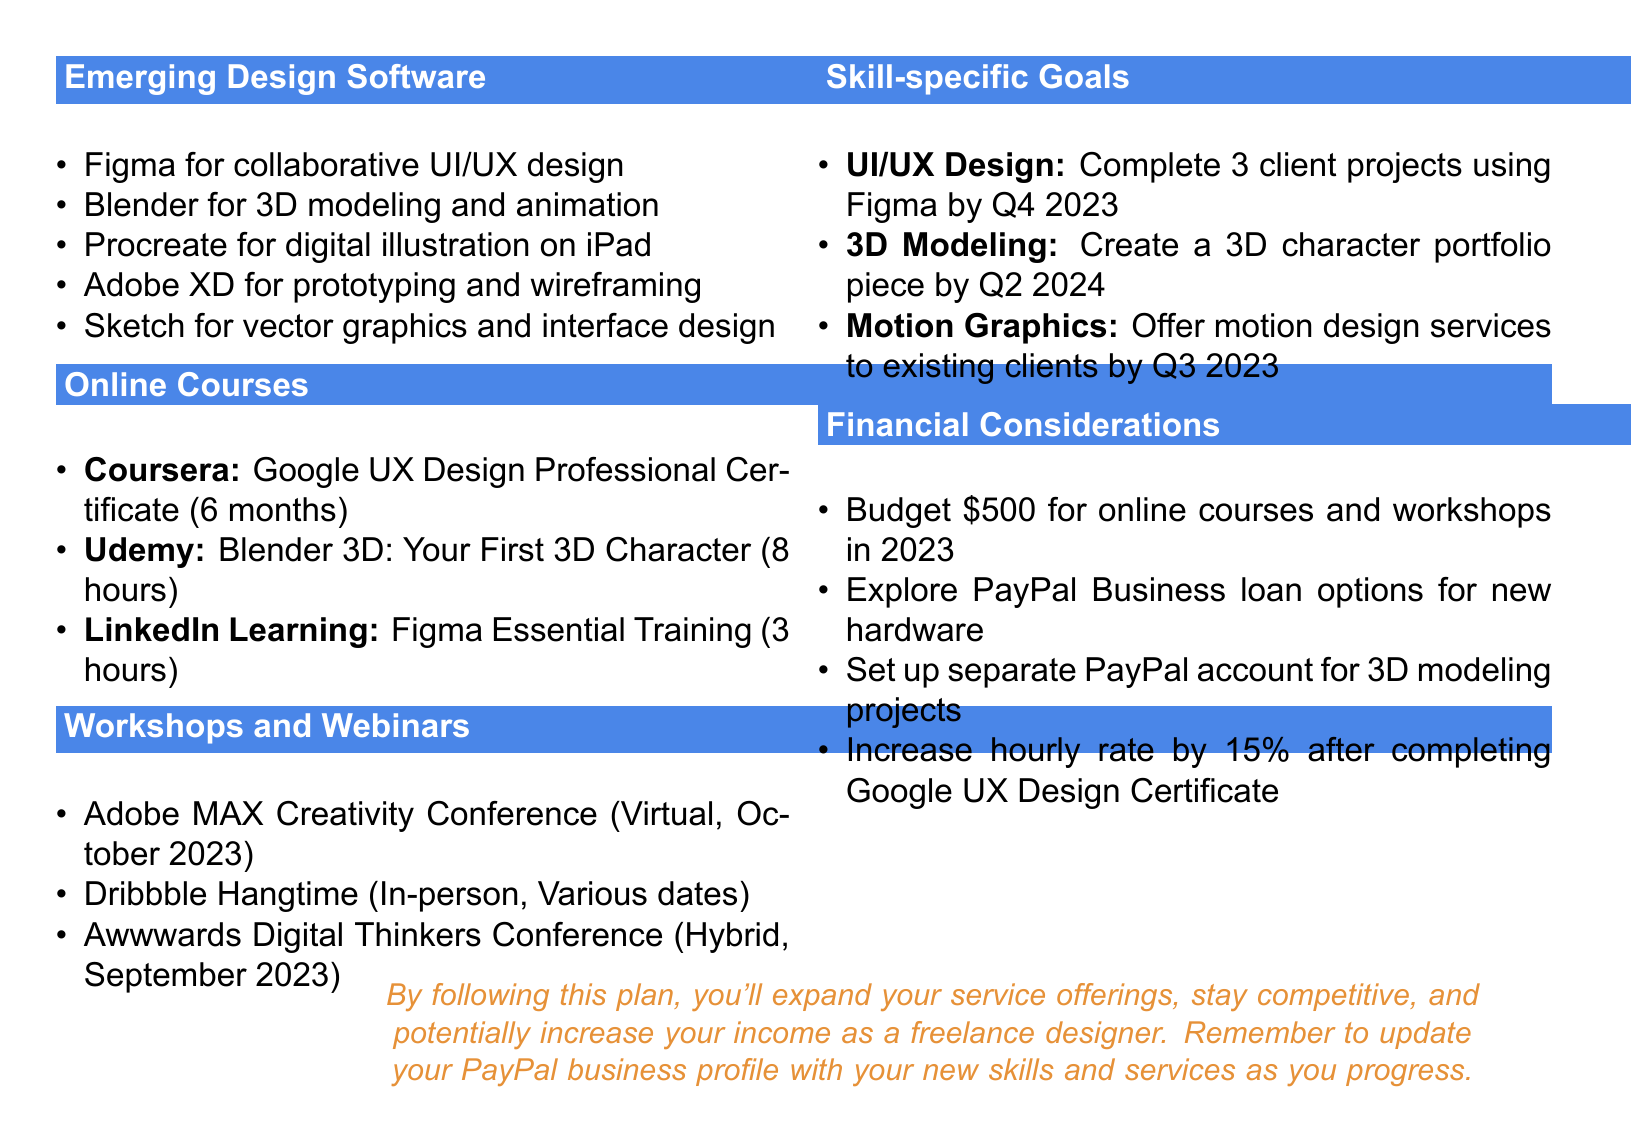What is the title of the document? The title is specified at the beginning of the document and is "Personal Skill Development Plan for Freelance Designers."
Answer: Personal Skill Development Plan for Freelance Designers What software is recommended for 3D modeling? "Blender" is mentioned in the section about emerging design software as a tool for 3D modeling and animation.
Answer: Blender How many hours is the Figma Essential Training course? The document specifies the duration of the course as "3 hours."
Answer: 3 hours When is the Adobe MAX Creativity Conference scheduled? The document states that the Adobe MAX Creativity Conference will take place in "October 2023."
Answer: October 2023 What skill-specific goal is related to motion graphics? It specifies that the goal is to "offer motion design services to existing clients by Q3 2023," making it clear what is aimed for in motion graphics.
Answer: Offer motion design services to existing clients by Q3 2023 What percentage increase in the hourly rate is recommended after completing the Google UX Design Certificate? The document mentions an increase of "15%" is suggested after completing the course.
Answer: 15% How much budget is allocated for online courses and workshops in 2023? The financial section noted a budget allocation of "$500" for courses and workshops.
Answer: $500 What is the format of the Dribbble Hangtime event? The document describes the format as "In-person."
Answer: In-person What is the focus of the Awwwards Digital Thinkers Conference? The document mentions that the conference focuses on "web design trends and best practices."
Answer: Web design trends and best practices 